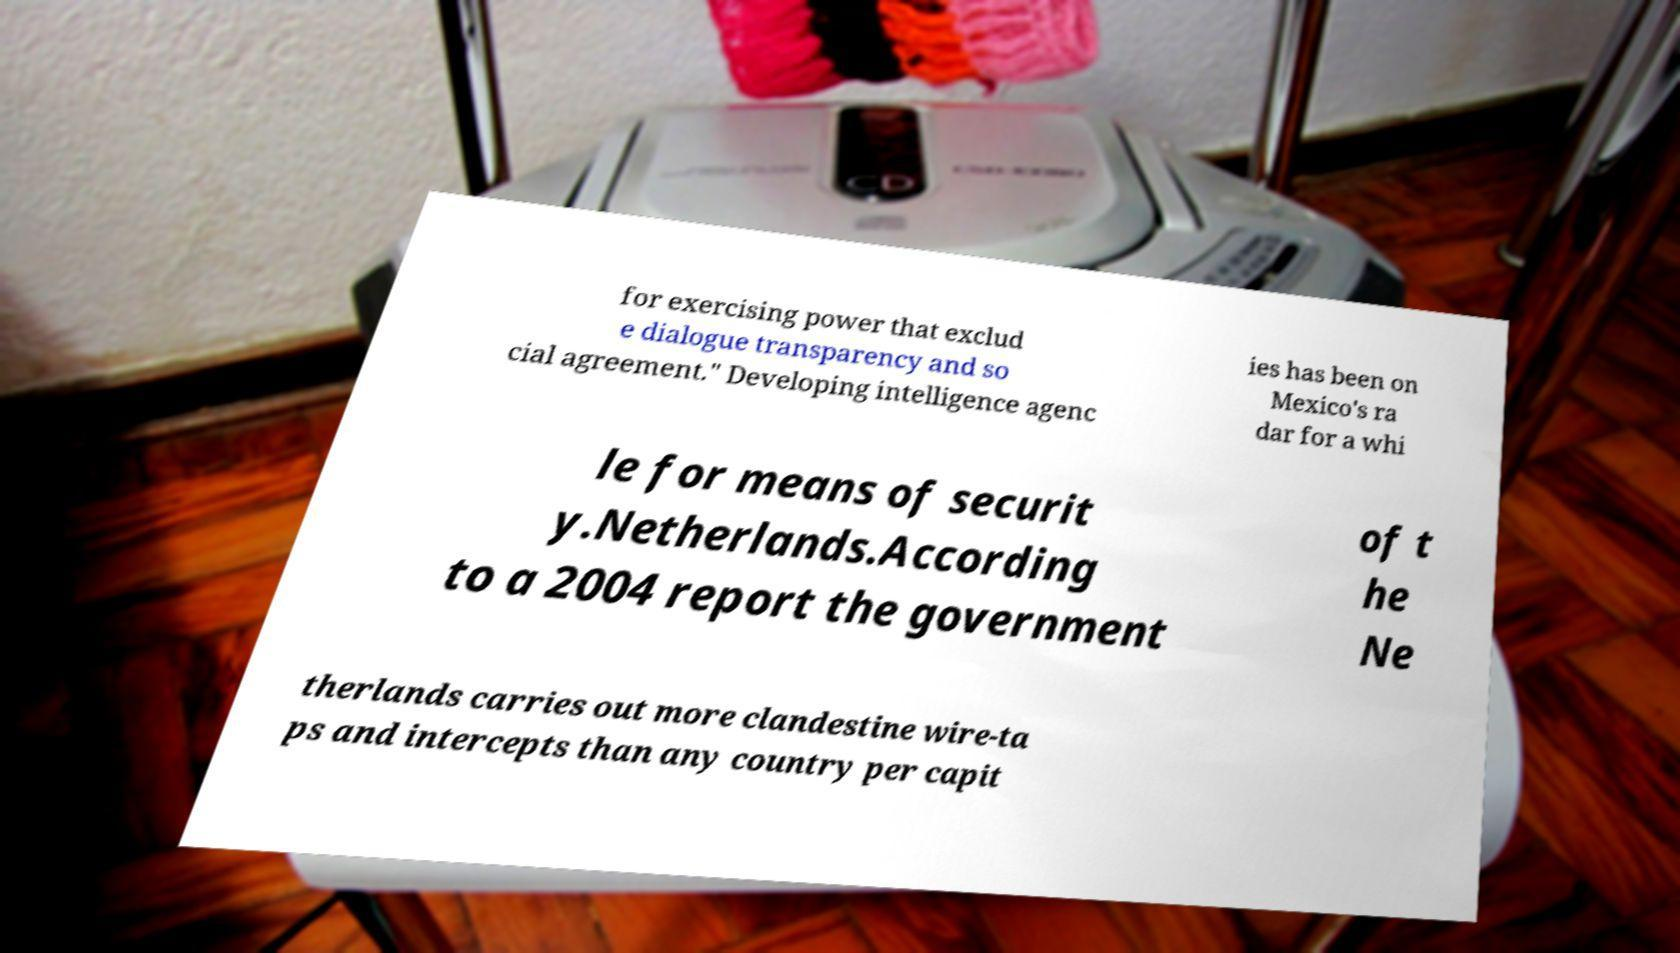For documentation purposes, I need the text within this image transcribed. Could you provide that? for exercising power that exclud e dialogue transparency and so cial agreement." Developing intelligence agenc ies has been on Mexico's ra dar for a whi le for means of securit y.Netherlands.According to a 2004 report the government of t he Ne therlands carries out more clandestine wire-ta ps and intercepts than any country per capit 